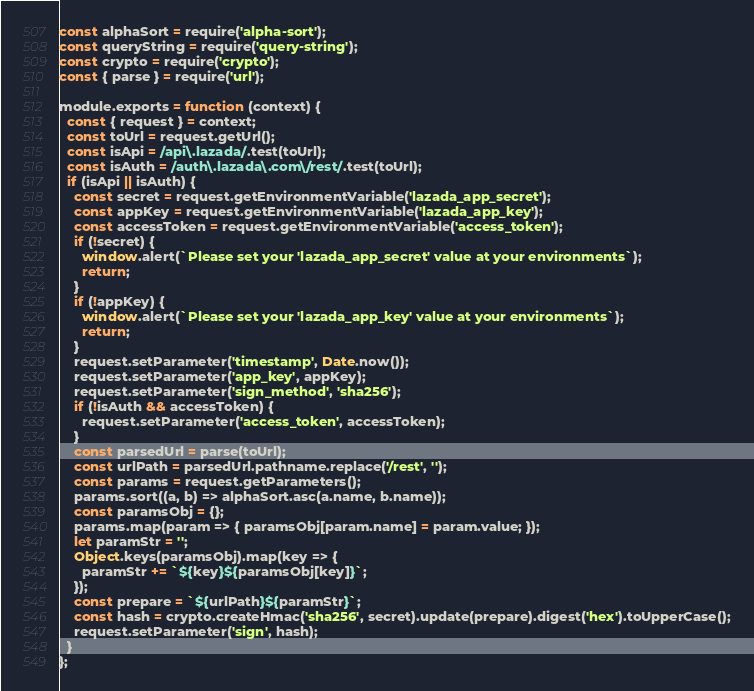Convert code to text. <code><loc_0><loc_0><loc_500><loc_500><_JavaScript_>const alphaSort = require('alpha-sort');
const queryString = require('query-string');
const crypto = require('crypto');
const { parse } = require('url');

module.exports = function (context) {
  const { request } = context;
  const toUrl = request.getUrl();
  const isApi = /api\.lazada/.test(toUrl);
  const isAuth = /auth\.lazada\.com\/rest/.test(toUrl);
  if (isApi || isAuth) {
    const secret = request.getEnvironmentVariable('lazada_app_secret');
    const appKey = request.getEnvironmentVariable('lazada_app_key');
    const accessToken = request.getEnvironmentVariable('access_token');
    if (!secret) {
      window.alert(`Please set your 'lazada_app_secret' value at your environments`);
      return;
    }
    if (!appKey) {
      window.alert(`Please set your 'lazada_app_key' value at your environments`);
      return;
    }
    request.setParameter('timestamp', Date.now());
    request.setParameter('app_key', appKey);
    request.setParameter('sign_method', 'sha256');
    if (!isAuth && accessToken) {
      request.setParameter('access_token', accessToken);
    }
    const parsedUrl = parse(toUrl);
    const urlPath = parsedUrl.pathname.replace('/rest', '');
    const params = request.getParameters();
    params.sort((a, b) => alphaSort.asc(a.name, b.name));
    const paramsObj = {};
    params.map(param => { paramsObj[param.name] = param.value; });
    let paramStr = '';
    Object.keys(paramsObj).map(key => {
      paramStr += `${key}${paramsObj[key]}`;
    });
    const prepare = `${urlPath}${paramStr}`;
    const hash = crypto.createHmac('sha256', secret).update(prepare).digest('hex').toUpperCase();
    request.setParameter('sign', hash);
  }
};</code> 